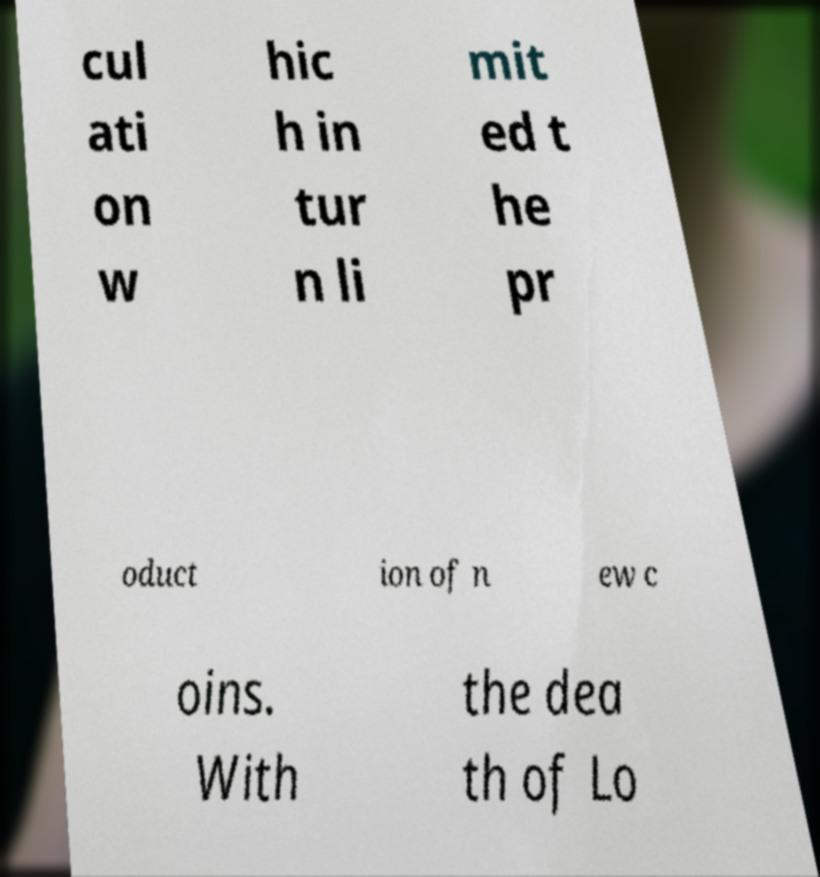There's text embedded in this image that I need extracted. Can you transcribe it verbatim? cul ati on w hic h in tur n li mit ed t he pr oduct ion of n ew c oins. With the dea th of Lo 